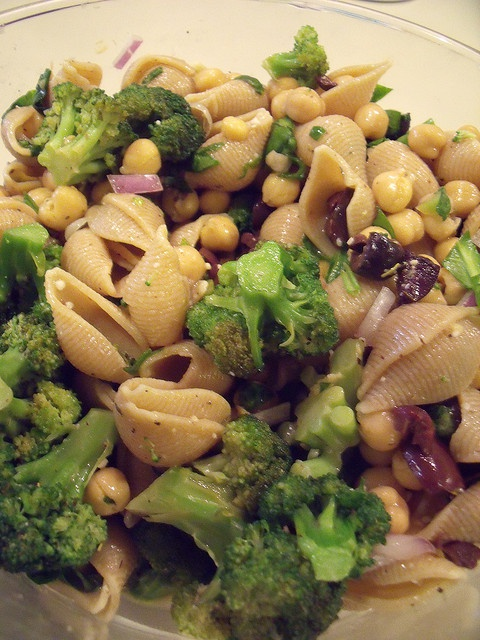Describe the objects in this image and their specific colors. I can see bowl in olive, black, and tan tones, broccoli in tan, darkgreen, black, and olive tones, broccoli in tan, darkgreen, black, and olive tones, broccoli in tan, darkgreen, black, and olive tones, and broccoli in tan, olive, and khaki tones in this image. 